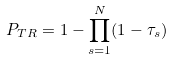Convert formula to latex. <formula><loc_0><loc_0><loc_500><loc_500>P _ { T R } = 1 - \prod _ { s = 1 } ^ { N } ( 1 - \tau _ { s } )</formula> 